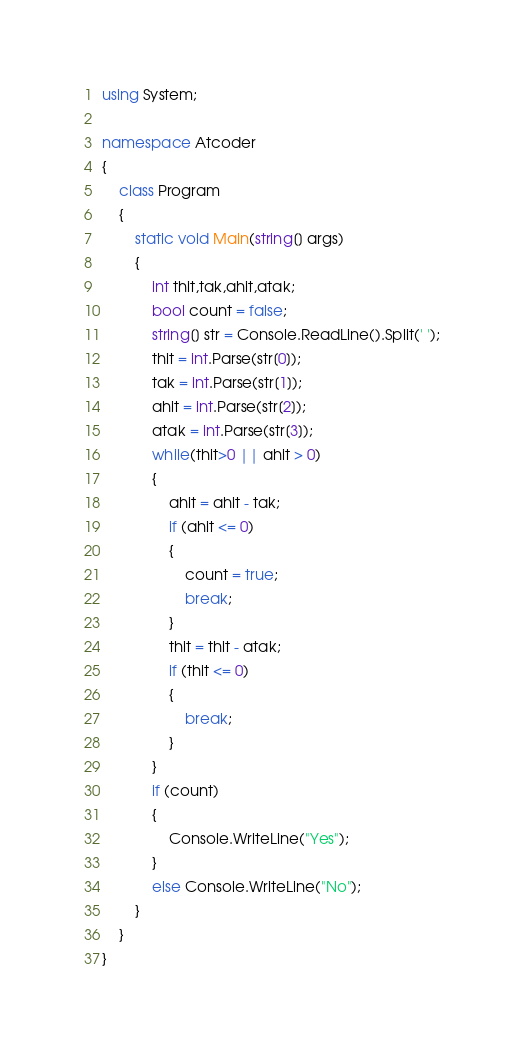Convert code to text. <code><loc_0><loc_0><loc_500><loc_500><_C#_>using System;

namespace Atcoder
{
    class Program
    {
        static void Main(string[] args)
        {
            int thit,tak,ahit,atak;
            bool count = false;
            string[] str = Console.ReadLine().Split(' ');
            thit = int.Parse(str[0]);
            tak = int.Parse(str[1]);
            ahit = int.Parse(str[2]);
            atak = int.Parse(str[3]);
            while(thit>0 || ahit > 0)
            {
                ahit = ahit - tak;
                if (ahit <= 0)
                {
                    count = true;
                    break;
                }
                thit = thit - atak;
                if (thit <= 0)
                {
                    break;
                }
            }
            if (count)
            {
                Console.WriteLine("Yes");
            }
            else Console.WriteLine("No");
        }
    }
}
</code> 